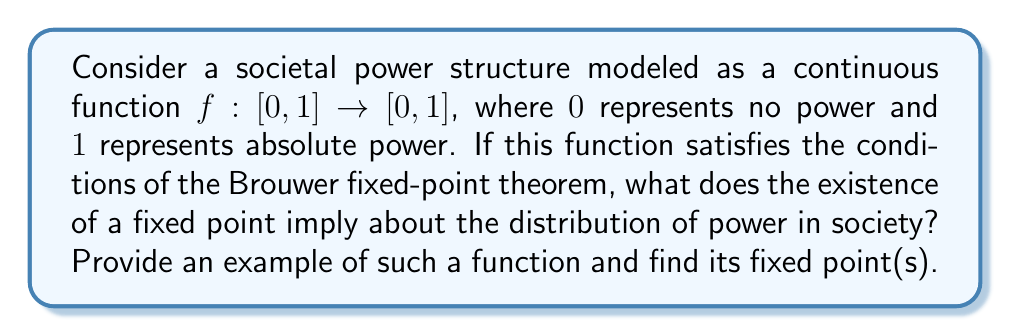What is the answer to this math problem? To approach this problem, let's break it down into steps:

1) The Brouwer fixed-point theorem states that for any continuous function $f$ from a compact convex set to itself, there is at least one fixed point. In this case, our set is $[0,1]$, which is indeed compact and convex.

2) A fixed point of $f$ is a point $x$ such that $f(x) = x$. In the context of our power structure model, this represents a level of power that reproduces itself.

3) The existence of a fixed point implies that there is at least one power level that remains stable under the dynamics of the system. This could represent a form of equilibrium in the power structure.

4) Let's consider an example function that could model a power structure:

   $$f(x) = \frac{x^2 + x}{2}$$

   This function maps $[0,1]$ to $[0,1]$ and is continuous.

5) To find the fixed points, we solve the equation:

   $$f(x) = x$$
   $$\frac{x^2 + x}{2} = x$$
   $$x^2 + x = 2x$$
   $$x^2 - x = 0$$
   $$x(x-1) = 0$$

6) Solving this equation, we find two fixed points: $x = 0$ and $x = 1$.

7) These fixed points represent two stable states in our power structure:
   - $x = 0$: A state where those without power remain without power
   - $x = 1$: A state where those with absolute power maintain absolute power

8) The existence of multiple fixed points suggests that this power structure has multiple possible stable configurations.

This mathematical model, while simplified, provides a framework for discussing power dynamics in society, a topic often explored in the "Against Everyone With Conner Habib" podcast.
Answer: The fixed points of the function $f(x) = \frac{x^2 + x}{2}$ are $x = 0$ and $x = 1$. These represent stable states in the power structure where no power (0) and absolute power (1) are self-reproducing. 